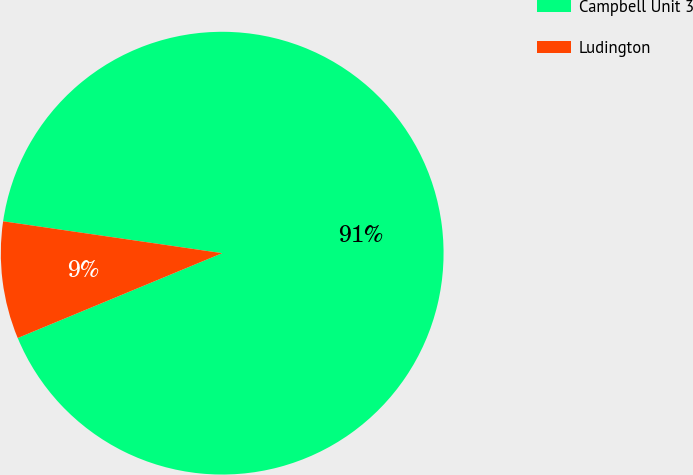<chart> <loc_0><loc_0><loc_500><loc_500><pie_chart><fcel>Campbell Unit 3<fcel>Ludington<nl><fcel>91.44%<fcel>8.56%<nl></chart> 